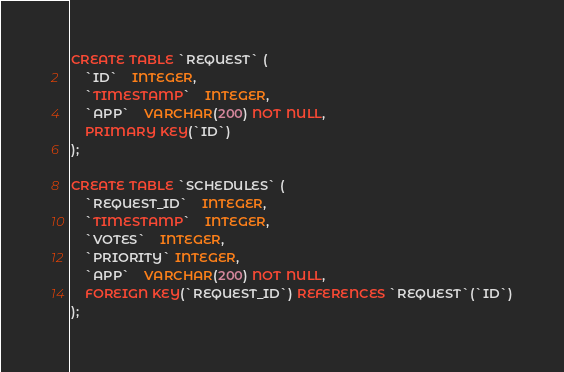<code> <loc_0><loc_0><loc_500><loc_500><_SQL_>CREATE TABLE `REQUEST` (
	`ID`	INTEGER,
	`TIMESTAMP`	INTEGER,
	`APP`	VARCHAR(200) NOT NULL,
	PRIMARY KEY(`ID`)
);

CREATE TABLE `SCHEDULES` (
	`REQUEST_ID`	INTEGER,
	`TIMESTAMP`	INTEGER,
	`VOTES`	INTEGER,
	`PRIORITY` INTEGER,
	`APP`	VARCHAR(200) NOT NULL,
	FOREIGN KEY(`REQUEST_ID`) REFERENCES `REQUEST`(`ID`)
);</code> 